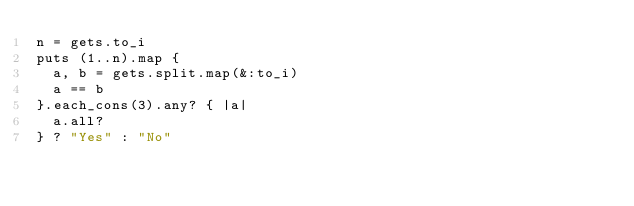Convert code to text. <code><loc_0><loc_0><loc_500><loc_500><_Ruby_>n = gets.to_i
puts (1..n).map {
	a, b = gets.split.map(&:to_i)
	a == b
}.each_cons(3).any? { |a|
	a.all?
} ? "Yes" : "No"
</code> 